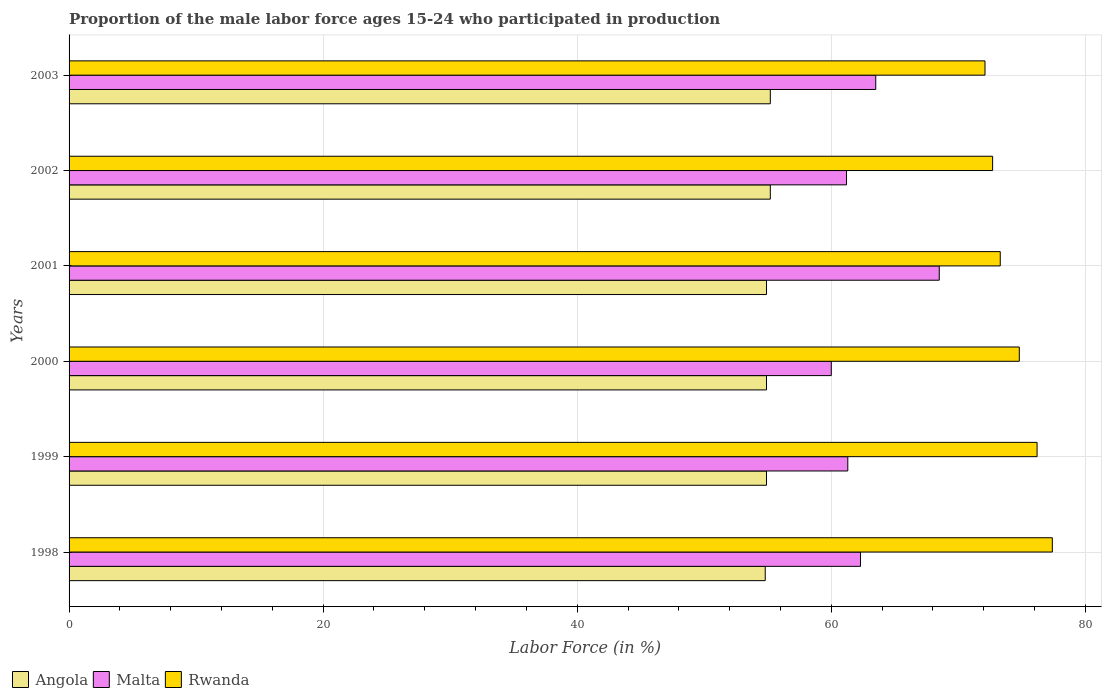How many different coloured bars are there?
Keep it short and to the point. 3. How many groups of bars are there?
Give a very brief answer. 6. Are the number of bars per tick equal to the number of legend labels?
Make the answer very short. Yes. What is the label of the 3rd group of bars from the top?
Offer a very short reply. 2001. In how many cases, is the number of bars for a given year not equal to the number of legend labels?
Your response must be concise. 0. What is the proportion of the male labor force who participated in production in Rwanda in 1999?
Your answer should be compact. 76.2. Across all years, what is the maximum proportion of the male labor force who participated in production in Rwanda?
Provide a short and direct response. 77.4. What is the total proportion of the male labor force who participated in production in Rwanda in the graph?
Your answer should be compact. 446.5. What is the difference between the proportion of the male labor force who participated in production in Rwanda in 2000 and that in 2002?
Provide a succinct answer. 2.1. What is the difference between the proportion of the male labor force who participated in production in Rwanda in 1999 and the proportion of the male labor force who participated in production in Angola in 2001?
Provide a short and direct response. 21.3. What is the average proportion of the male labor force who participated in production in Malta per year?
Provide a short and direct response. 62.8. In the year 2003, what is the difference between the proportion of the male labor force who participated in production in Angola and proportion of the male labor force who participated in production in Rwanda?
Your response must be concise. -16.9. In how many years, is the proportion of the male labor force who participated in production in Malta greater than 76 %?
Offer a very short reply. 0. What is the ratio of the proportion of the male labor force who participated in production in Malta in 1999 to that in 2001?
Your answer should be compact. 0.89. Is the proportion of the male labor force who participated in production in Rwanda in 1998 less than that in 2000?
Provide a short and direct response. No. What is the difference between the highest and the lowest proportion of the male labor force who participated in production in Rwanda?
Your answer should be very brief. 5.3. Is the sum of the proportion of the male labor force who participated in production in Malta in 2000 and 2001 greater than the maximum proportion of the male labor force who participated in production in Angola across all years?
Give a very brief answer. Yes. What does the 3rd bar from the top in 2000 represents?
Your answer should be compact. Angola. What does the 1st bar from the bottom in 2001 represents?
Provide a short and direct response. Angola. Are all the bars in the graph horizontal?
Make the answer very short. Yes. What is the difference between two consecutive major ticks on the X-axis?
Offer a terse response. 20. Are the values on the major ticks of X-axis written in scientific E-notation?
Provide a short and direct response. No. Does the graph contain any zero values?
Provide a short and direct response. No. Does the graph contain grids?
Your response must be concise. Yes. Where does the legend appear in the graph?
Your answer should be compact. Bottom left. How many legend labels are there?
Your answer should be compact. 3. How are the legend labels stacked?
Keep it short and to the point. Horizontal. What is the title of the graph?
Ensure brevity in your answer.  Proportion of the male labor force ages 15-24 who participated in production. Does "Romania" appear as one of the legend labels in the graph?
Provide a short and direct response. No. What is the label or title of the X-axis?
Your response must be concise. Labor Force (in %). What is the Labor Force (in %) in Angola in 1998?
Your response must be concise. 54.8. What is the Labor Force (in %) in Malta in 1998?
Give a very brief answer. 62.3. What is the Labor Force (in %) of Rwanda in 1998?
Provide a short and direct response. 77.4. What is the Labor Force (in %) in Angola in 1999?
Your response must be concise. 54.9. What is the Labor Force (in %) of Malta in 1999?
Keep it short and to the point. 61.3. What is the Labor Force (in %) in Rwanda in 1999?
Provide a succinct answer. 76.2. What is the Labor Force (in %) in Angola in 2000?
Make the answer very short. 54.9. What is the Labor Force (in %) of Rwanda in 2000?
Give a very brief answer. 74.8. What is the Labor Force (in %) of Angola in 2001?
Your answer should be compact. 54.9. What is the Labor Force (in %) of Malta in 2001?
Your answer should be very brief. 68.5. What is the Labor Force (in %) of Rwanda in 2001?
Keep it short and to the point. 73.3. What is the Labor Force (in %) in Angola in 2002?
Ensure brevity in your answer.  55.2. What is the Labor Force (in %) of Malta in 2002?
Ensure brevity in your answer.  61.2. What is the Labor Force (in %) of Rwanda in 2002?
Ensure brevity in your answer.  72.7. What is the Labor Force (in %) of Angola in 2003?
Your answer should be compact. 55.2. What is the Labor Force (in %) in Malta in 2003?
Provide a short and direct response. 63.5. What is the Labor Force (in %) in Rwanda in 2003?
Make the answer very short. 72.1. Across all years, what is the maximum Labor Force (in %) in Angola?
Your answer should be compact. 55.2. Across all years, what is the maximum Labor Force (in %) of Malta?
Provide a short and direct response. 68.5. Across all years, what is the maximum Labor Force (in %) in Rwanda?
Your answer should be very brief. 77.4. Across all years, what is the minimum Labor Force (in %) in Angola?
Give a very brief answer. 54.8. Across all years, what is the minimum Labor Force (in %) in Malta?
Make the answer very short. 60. Across all years, what is the minimum Labor Force (in %) in Rwanda?
Your answer should be compact. 72.1. What is the total Labor Force (in %) in Angola in the graph?
Ensure brevity in your answer.  329.9. What is the total Labor Force (in %) of Malta in the graph?
Make the answer very short. 376.8. What is the total Labor Force (in %) of Rwanda in the graph?
Your response must be concise. 446.5. What is the difference between the Labor Force (in %) of Angola in 1998 and that in 1999?
Your answer should be very brief. -0.1. What is the difference between the Labor Force (in %) of Malta in 1998 and that in 1999?
Make the answer very short. 1. What is the difference between the Labor Force (in %) in Rwanda in 1998 and that in 1999?
Keep it short and to the point. 1.2. What is the difference between the Labor Force (in %) of Rwanda in 1998 and that in 2000?
Your answer should be compact. 2.6. What is the difference between the Labor Force (in %) in Angola in 1998 and that in 2001?
Your answer should be very brief. -0.1. What is the difference between the Labor Force (in %) of Rwanda in 1998 and that in 2001?
Keep it short and to the point. 4.1. What is the difference between the Labor Force (in %) in Angola in 1998 and that in 2002?
Provide a succinct answer. -0.4. What is the difference between the Labor Force (in %) of Malta in 1998 and that in 2002?
Offer a terse response. 1.1. What is the difference between the Labor Force (in %) in Rwanda in 1998 and that in 2003?
Provide a short and direct response. 5.3. What is the difference between the Labor Force (in %) of Angola in 1999 and that in 2000?
Offer a terse response. 0. What is the difference between the Labor Force (in %) of Angola in 1999 and that in 2001?
Provide a short and direct response. 0. What is the difference between the Labor Force (in %) in Rwanda in 1999 and that in 2001?
Provide a short and direct response. 2.9. What is the difference between the Labor Force (in %) in Malta in 1999 and that in 2002?
Keep it short and to the point. 0.1. What is the difference between the Labor Force (in %) of Angola in 2000 and that in 2001?
Offer a very short reply. 0. What is the difference between the Labor Force (in %) of Angola in 2000 and that in 2003?
Provide a succinct answer. -0.3. What is the difference between the Labor Force (in %) in Malta in 2000 and that in 2003?
Your answer should be compact. -3.5. What is the difference between the Labor Force (in %) of Malta in 2001 and that in 2002?
Ensure brevity in your answer.  7.3. What is the difference between the Labor Force (in %) of Angola in 2001 and that in 2003?
Give a very brief answer. -0.3. What is the difference between the Labor Force (in %) of Malta in 2002 and that in 2003?
Offer a terse response. -2.3. What is the difference between the Labor Force (in %) of Angola in 1998 and the Labor Force (in %) of Malta in 1999?
Give a very brief answer. -6.5. What is the difference between the Labor Force (in %) of Angola in 1998 and the Labor Force (in %) of Rwanda in 1999?
Ensure brevity in your answer.  -21.4. What is the difference between the Labor Force (in %) in Angola in 1998 and the Labor Force (in %) in Malta in 2000?
Keep it short and to the point. -5.2. What is the difference between the Labor Force (in %) in Malta in 1998 and the Labor Force (in %) in Rwanda in 2000?
Make the answer very short. -12.5. What is the difference between the Labor Force (in %) of Angola in 1998 and the Labor Force (in %) of Malta in 2001?
Give a very brief answer. -13.7. What is the difference between the Labor Force (in %) in Angola in 1998 and the Labor Force (in %) in Rwanda in 2001?
Offer a very short reply. -18.5. What is the difference between the Labor Force (in %) in Malta in 1998 and the Labor Force (in %) in Rwanda in 2001?
Your response must be concise. -11. What is the difference between the Labor Force (in %) of Angola in 1998 and the Labor Force (in %) of Malta in 2002?
Offer a terse response. -6.4. What is the difference between the Labor Force (in %) in Angola in 1998 and the Labor Force (in %) in Rwanda in 2002?
Provide a short and direct response. -17.9. What is the difference between the Labor Force (in %) in Angola in 1998 and the Labor Force (in %) in Malta in 2003?
Your response must be concise. -8.7. What is the difference between the Labor Force (in %) in Angola in 1998 and the Labor Force (in %) in Rwanda in 2003?
Ensure brevity in your answer.  -17.3. What is the difference between the Labor Force (in %) of Angola in 1999 and the Labor Force (in %) of Rwanda in 2000?
Your answer should be very brief. -19.9. What is the difference between the Labor Force (in %) in Angola in 1999 and the Labor Force (in %) in Malta in 2001?
Your answer should be very brief. -13.6. What is the difference between the Labor Force (in %) of Angola in 1999 and the Labor Force (in %) of Rwanda in 2001?
Your answer should be very brief. -18.4. What is the difference between the Labor Force (in %) of Malta in 1999 and the Labor Force (in %) of Rwanda in 2001?
Make the answer very short. -12. What is the difference between the Labor Force (in %) of Angola in 1999 and the Labor Force (in %) of Malta in 2002?
Offer a terse response. -6.3. What is the difference between the Labor Force (in %) in Angola in 1999 and the Labor Force (in %) in Rwanda in 2002?
Make the answer very short. -17.8. What is the difference between the Labor Force (in %) of Malta in 1999 and the Labor Force (in %) of Rwanda in 2002?
Make the answer very short. -11.4. What is the difference between the Labor Force (in %) of Angola in 1999 and the Labor Force (in %) of Malta in 2003?
Give a very brief answer. -8.6. What is the difference between the Labor Force (in %) of Angola in 1999 and the Labor Force (in %) of Rwanda in 2003?
Keep it short and to the point. -17.2. What is the difference between the Labor Force (in %) of Angola in 2000 and the Labor Force (in %) of Rwanda in 2001?
Give a very brief answer. -18.4. What is the difference between the Labor Force (in %) in Malta in 2000 and the Labor Force (in %) in Rwanda in 2001?
Give a very brief answer. -13.3. What is the difference between the Labor Force (in %) of Angola in 2000 and the Labor Force (in %) of Rwanda in 2002?
Your answer should be compact. -17.8. What is the difference between the Labor Force (in %) in Malta in 2000 and the Labor Force (in %) in Rwanda in 2002?
Offer a terse response. -12.7. What is the difference between the Labor Force (in %) of Angola in 2000 and the Labor Force (in %) of Rwanda in 2003?
Your answer should be compact. -17.2. What is the difference between the Labor Force (in %) of Angola in 2001 and the Labor Force (in %) of Rwanda in 2002?
Provide a short and direct response. -17.8. What is the difference between the Labor Force (in %) in Malta in 2001 and the Labor Force (in %) in Rwanda in 2002?
Give a very brief answer. -4.2. What is the difference between the Labor Force (in %) of Angola in 2001 and the Labor Force (in %) of Rwanda in 2003?
Ensure brevity in your answer.  -17.2. What is the difference between the Labor Force (in %) in Angola in 2002 and the Labor Force (in %) in Malta in 2003?
Make the answer very short. -8.3. What is the difference between the Labor Force (in %) of Angola in 2002 and the Labor Force (in %) of Rwanda in 2003?
Provide a short and direct response. -16.9. What is the average Labor Force (in %) of Angola per year?
Ensure brevity in your answer.  54.98. What is the average Labor Force (in %) in Malta per year?
Keep it short and to the point. 62.8. What is the average Labor Force (in %) in Rwanda per year?
Your answer should be very brief. 74.42. In the year 1998, what is the difference between the Labor Force (in %) of Angola and Labor Force (in %) of Malta?
Offer a very short reply. -7.5. In the year 1998, what is the difference between the Labor Force (in %) in Angola and Labor Force (in %) in Rwanda?
Your response must be concise. -22.6. In the year 1998, what is the difference between the Labor Force (in %) of Malta and Labor Force (in %) of Rwanda?
Make the answer very short. -15.1. In the year 1999, what is the difference between the Labor Force (in %) in Angola and Labor Force (in %) in Malta?
Your response must be concise. -6.4. In the year 1999, what is the difference between the Labor Force (in %) in Angola and Labor Force (in %) in Rwanda?
Offer a terse response. -21.3. In the year 1999, what is the difference between the Labor Force (in %) in Malta and Labor Force (in %) in Rwanda?
Provide a succinct answer. -14.9. In the year 2000, what is the difference between the Labor Force (in %) of Angola and Labor Force (in %) of Rwanda?
Give a very brief answer. -19.9. In the year 2000, what is the difference between the Labor Force (in %) of Malta and Labor Force (in %) of Rwanda?
Provide a succinct answer. -14.8. In the year 2001, what is the difference between the Labor Force (in %) of Angola and Labor Force (in %) of Rwanda?
Your response must be concise. -18.4. In the year 2001, what is the difference between the Labor Force (in %) of Malta and Labor Force (in %) of Rwanda?
Give a very brief answer. -4.8. In the year 2002, what is the difference between the Labor Force (in %) of Angola and Labor Force (in %) of Malta?
Offer a very short reply. -6. In the year 2002, what is the difference between the Labor Force (in %) of Angola and Labor Force (in %) of Rwanda?
Give a very brief answer. -17.5. In the year 2003, what is the difference between the Labor Force (in %) of Angola and Labor Force (in %) of Malta?
Keep it short and to the point. -8.3. In the year 2003, what is the difference between the Labor Force (in %) of Angola and Labor Force (in %) of Rwanda?
Your answer should be compact. -16.9. In the year 2003, what is the difference between the Labor Force (in %) in Malta and Labor Force (in %) in Rwanda?
Your answer should be compact. -8.6. What is the ratio of the Labor Force (in %) of Angola in 1998 to that in 1999?
Your answer should be compact. 1. What is the ratio of the Labor Force (in %) in Malta in 1998 to that in 1999?
Your answer should be compact. 1.02. What is the ratio of the Labor Force (in %) in Rwanda in 1998 to that in 1999?
Offer a very short reply. 1.02. What is the ratio of the Labor Force (in %) in Malta in 1998 to that in 2000?
Ensure brevity in your answer.  1.04. What is the ratio of the Labor Force (in %) in Rwanda in 1998 to that in 2000?
Give a very brief answer. 1.03. What is the ratio of the Labor Force (in %) of Malta in 1998 to that in 2001?
Make the answer very short. 0.91. What is the ratio of the Labor Force (in %) of Rwanda in 1998 to that in 2001?
Offer a terse response. 1.06. What is the ratio of the Labor Force (in %) in Angola in 1998 to that in 2002?
Make the answer very short. 0.99. What is the ratio of the Labor Force (in %) in Malta in 1998 to that in 2002?
Provide a succinct answer. 1.02. What is the ratio of the Labor Force (in %) of Rwanda in 1998 to that in 2002?
Your response must be concise. 1.06. What is the ratio of the Labor Force (in %) in Angola in 1998 to that in 2003?
Make the answer very short. 0.99. What is the ratio of the Labor Force (in %) of Malta in 1998 to that in 2003?
Offer a terse response. 0.98. What is the ratio of the Labor Force (in %) of Rwanda in 1998 to that in 2003?
Your answer should be very brief. 1.07. What is the ratio of the Labor Force (in %) of Angola in 1999 to that in 2000?
Offer a terse response. 1. What is the ratio of the Labor Force (in %) in Malta in 1999 to that in 2000?
Provide a succinct answer. 1.02. What is the ratio of the Labor Force (in %) in Rwanda in 1999 to that in 2000?
Your answer should be compact. 1.02. What is the ratio of the Labor Force (in %) in Malta in 1999 to that in 2001?
Ensure brevity in your answer.  0.89. What is the ratio of the Labor Force (in %) of Rwanda in 1999 to that in 2001?
Keep it short and to the point. 1.04. What is the ratio of the Labor Force (in %) of Angola in 1999 to that in 2002?
Provide a succinct answer. 0.99. What is the ratio of the Labor Force (in %) in Rwanda in 1999 to that in 2002?
Offer a terse response. 1.05. What is the ratio of the Labor Force (in %) of Malta in 1999 to that in 2003?
Your answer should be compact. 0.97. What is the ratio of the Labor Force (in %) in Rwanda in 1999 to that in 2003?
Your answer should be very brief. 1.06. What is the ratio of the Labor Force (in %) of Angola in 2000 to that in 2001?
Your answer should be compact. 1. What is the ratio of the Labor Force (in %) of Malta in 2000 to that in 2001?
Provide a succinct answer. 0.88. What is the ratio of the Labor Force (in %) in Rwanda in 2000 to that in 2001?
Make the answer very short. 1.02. What is the ratio of the Labor Force (in %) of Malta in 2000 to that in 2002?
Provide a succinct answer. 0.98. What is the ratio of the Labor Force (in %) of Rwanda in 2000 to that in 2002?
Make the answer very short. 1.03. What is the ratio of the Labor Force (in %) of Malta in 2000 to that in 2003?
Offer a very short reply. 0.94. What is the ratio of the Labor Force (in %) in Rwanda in 2000 to that in 2003?
Provide a succinct answer. 1.04. What is the ratio of the Labor Force (in %) in Angola in 2001 to that in 2002?
Provide a short and direct response. 0.99. What is the ratio of the Labor Force (in %) of Malta in 2001 to that in 2002?
Make the answer very short. 1.12. What is the ratio of the Labor Force (in %) in Rwanda in 2001 to that in 2002?
Offer a very short reply. 1.01. What is the ratio of the Labor Force (in %) in Angola in 2001 to that in 2003?
Offer a very short reply. 0.99. What is the ratio of the Labor Force (in %) of Malta in 2001 to that in 2003?
Make the answer very short. 1.08. What is the ratio of the Labor Force (in %) of Rwanda in 2001 to that in 2003?
Ensure brevity in your answer.  1.02. What is the ratio of the Labor Force (in %) in Malta in 2002 to that in 2003?
Your answer should be compact. 0.96. What is the ratio of the Labor Force (in %) in Rwanda in 2002 to that in 2003?
Offer a very short reply. 1.01. What is the difference between the highest and the lowest Labor Force (in %) in Angola?
Offer a very short reply. 0.4. What is the difference between the highest and the lowest Labor Force (in %) in Malta?
Provide a succinct answer. 8.5. 